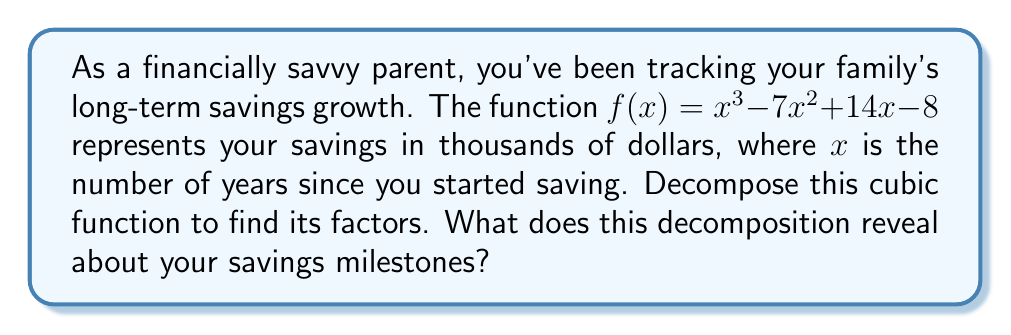Provide a solution to this math problem. Let's decompose the cubic function $f(x) = x^3 - 7x^2 + 14x - 8$ step by step:

1) First, let's check if there's a rational root. We can use the rational root theorem to find potential roots. The factors of the constant term (8) are ±1, ±2, ±4, ±8.

2) Testing these values, we find that $f(1) = 0$. So, $(x-1)$ is a factor.

3) We can use polynomial long division to divide $f(x)$ by $(x-1)$:

   $$\frac{x^3 - 7x^2 + 14x - 8}{x - 1} = x^2 - 6x + 8$$

4) So, $f(x) = (x-1)(x^2 - 6x + 8)$

5) Now, we need to factor the quadratic term $x^2 - 6x + 8$:
   - The sum of the roots is 6
   - The product of the roots is 8
   - The roots are 2 and 4

6) Therefore, $x^2 - 6x + 8 = (x-2)(x-4)$

7) Putting it all together: $f(x) = (x-1)(x-2)(x-4)$

This decomposition reveals that your savings will reach key milestones (in thousands of dollars) at 1 year, 2 years, and 4 years after you started saving.
Answer: $f(x) = (x-1)(x-2)(x-4)$ 